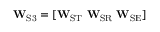Convert formula to latex. <formula><loc_0><loc_0><loc_500><loc_500>W _ { S 3 } = [ W _ { S T } \ W _ { S R } \ W _ { S E } ]</formula> 